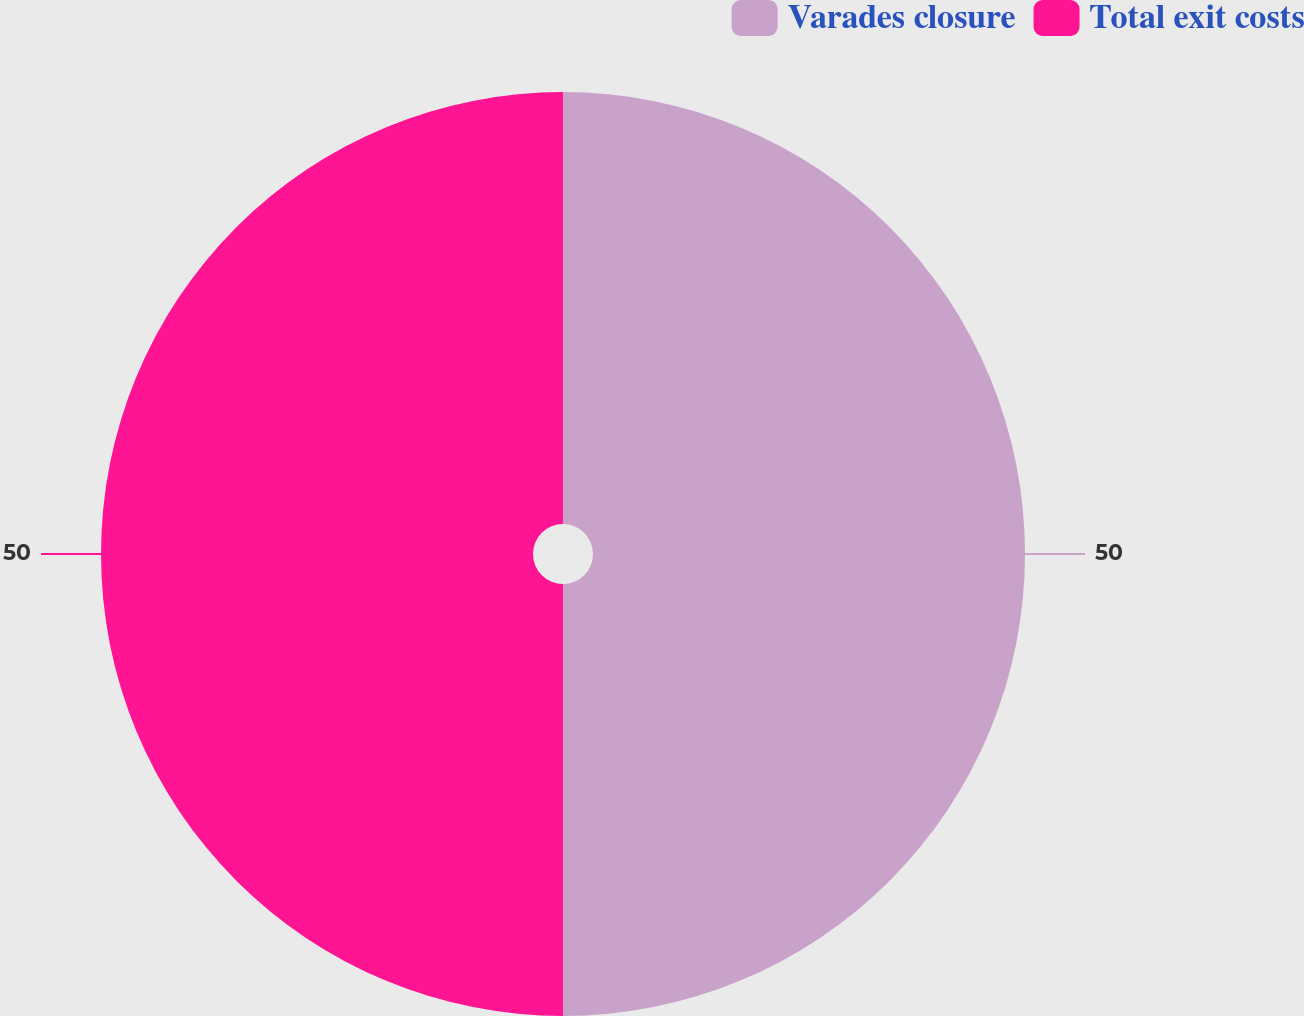Convert chart to OTSL. <chart><loc_0><loc_0><loc_500><loc_500><pie_chart><fcel>Varades closure<fcel>Total exit costs<nl><fcel>50.0%<fcel>50.0%<nl></chart> 